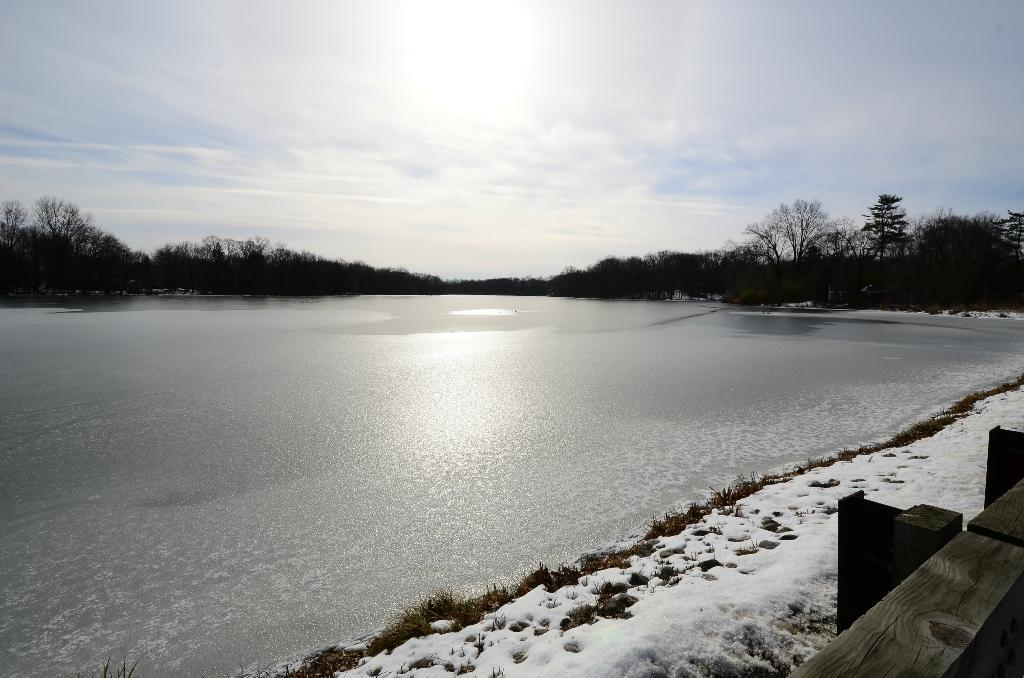What is the primary feature of the image? The primary feature of the image is a water surface. What is the condition of the land near the water? The land in front of the water is covered with snow. What can be seen in the background of the image? There are many trees in the background of the image. How many fingers can be seen holding a cake in the image? There are no fingers or cakes present in the image. What type of sail is visible in the image? There is no sail present in the image. 